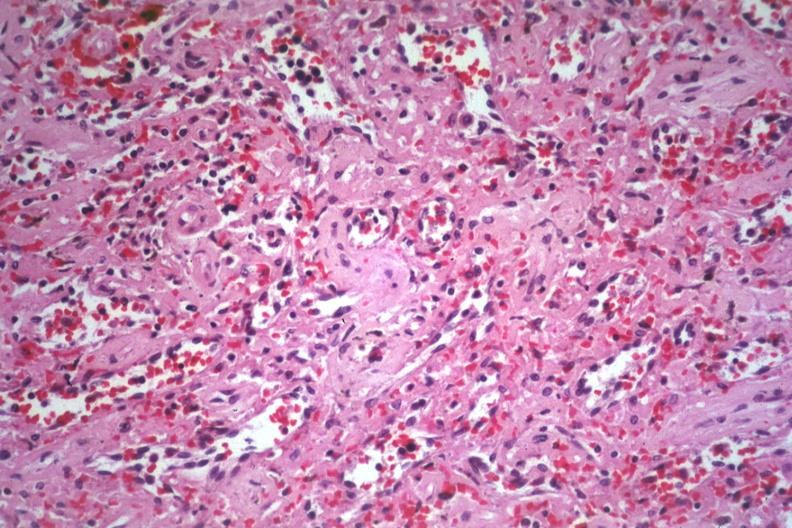s hematologic present?
Answer the question using a single word or phrase. Yes 